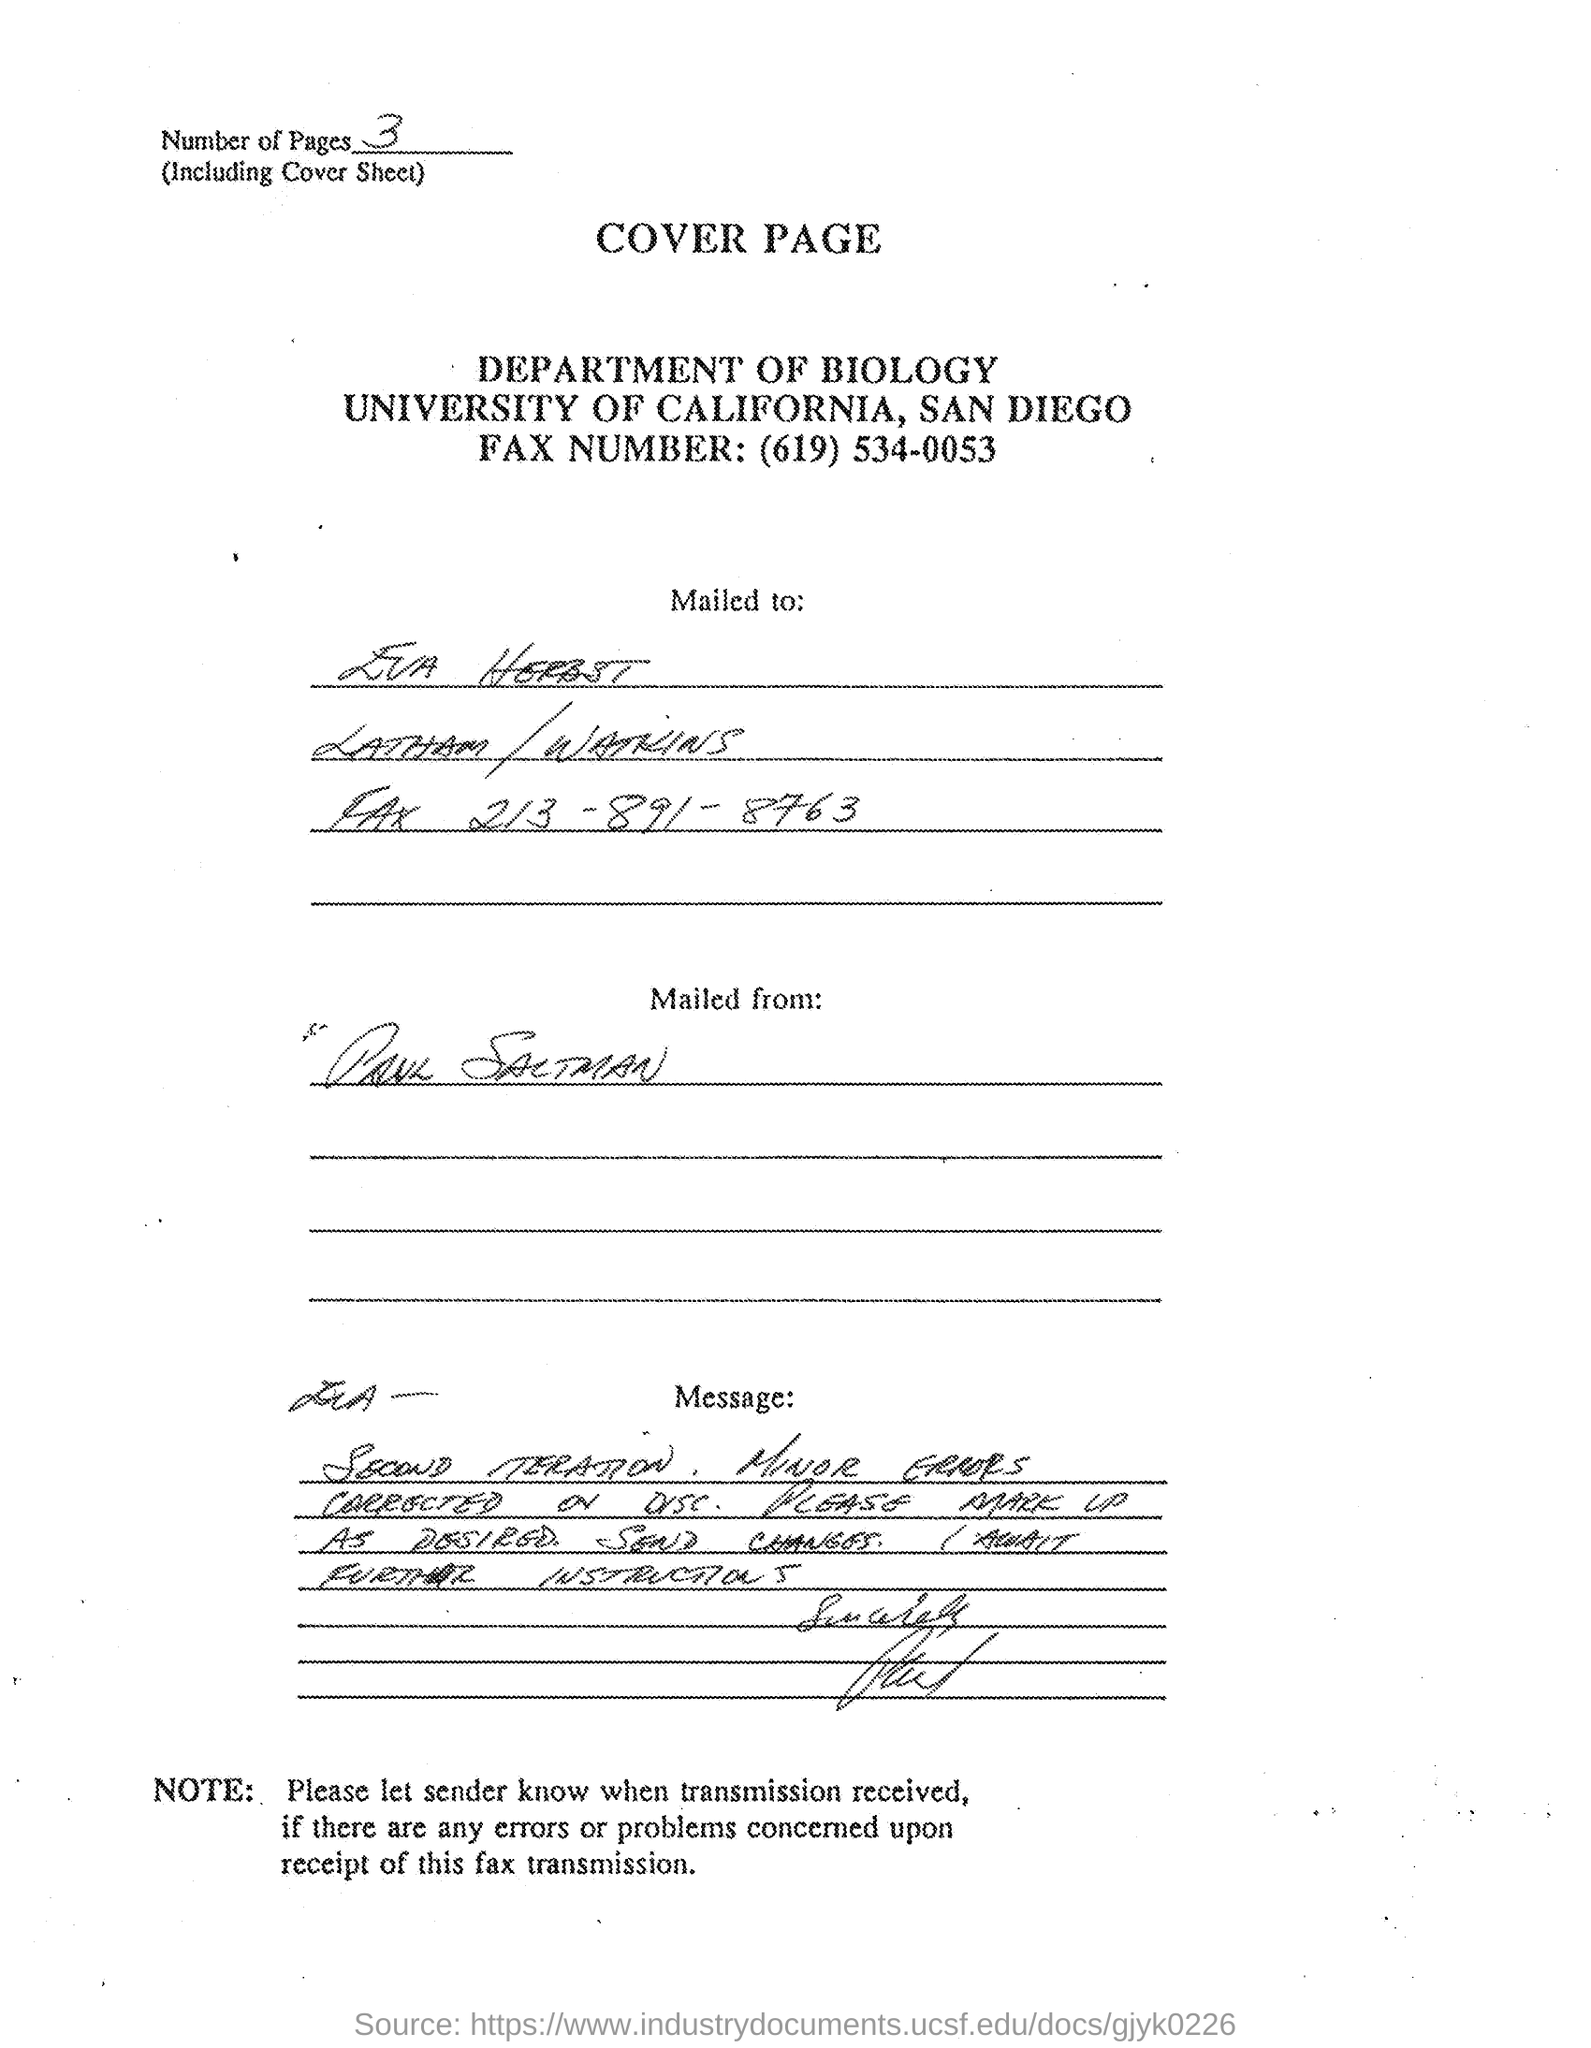What is senders name?
Your response must be concise. Paul saltman. Who is the receiver of the letter?
Your answer should be compact. EVA HERBST. 